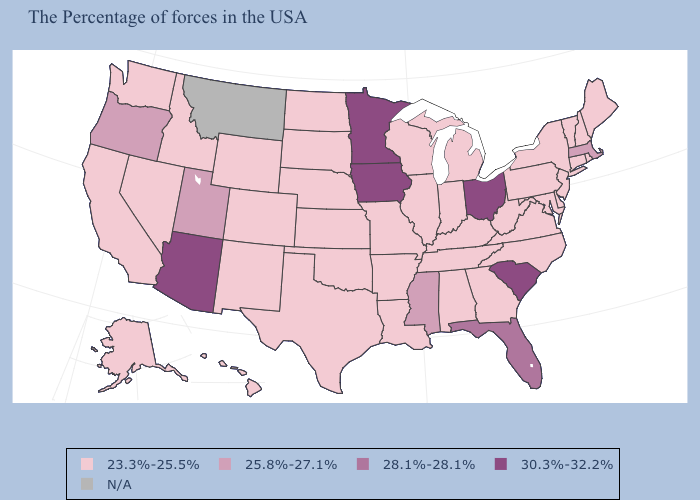Name the states that have a value in the range 25.8%-27.1%?
Keep it brief. Massachusetts, Mississippi, Utah, Oregon. Which states have the lowest value in the USA?
Quick response, please. Maine, Rhode Island, New Hampshire, Vermont, Connecticut, New York, New Jersey, Delaware, Maryland, Pennsylvania, Virginia, North Carolina, West Virginia, Georgia, Michigan, Kentucky, Indiana, Alabama, Tennessee, Wisconsin, Illinois, Louisiana, Missouri, Arkansas, Kansas, Nebraska, Oklahoma, Texas, South Dakota, North Dakota, Wyoming, Colorado, New Mexico, Idaho, Nevada, California, Washington, Alaska, Hawaii. What is the lowest value in the West?
Write a very short answer. 23.3%-25.5%. What is the value of Georgia?
Quick response, please. 23.3%-25.5%. Does Alabama have the highest value in the USA?
Short answer required. No. What is the value of Virginia?
Give a very brief answer. 23.3%-25.5%. Does the map have missing data?
Be succinct. Yes. What is the value of Montana?
Quick response, please. N/A. Name the states that have a value in the range 28.1%-28.1%?
Keep it brief. Florida. Does Ohio have the highest value in the MidWest?
Concise answer only. Yes. Which states have the lowest value in the USA?
Concise answer only. Maine, Rhode Island, New Hampshire, Vermont, Connecticut, New York, New Jersey, Delaware, Maryland, Pennsylvania, Virginia, North Carolina, West Virginia, Georgia, Michigan, Kentucky, Indiana, Alabama, Tennessee, Wisconsin, Illinois, Louisiana, Missouri, Arkansas, Kansas, Nebraska, Oklahoma, Texas, South Dakota, North Dakota, Wyoming, Colorado, New Mexico, Idaho, Nevada, California, Washington, Alaska, Hawaii. Name the states that have a value in the range N/A?
Keep it brief. Montana. What is the lowest value in states that border Nevada?
Answer briefly. 23.3%-25.5%. What is the lowest value in states that border Louisiana?
Keep it brief. 23.3%-25.5%. Among the states that border Idaho , which have the lowest value?
Keep it brief. Wyoming, Nevada, Washington. 